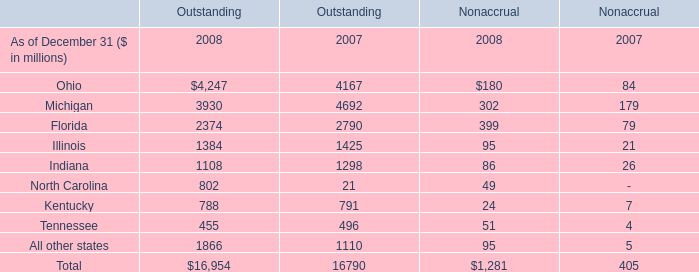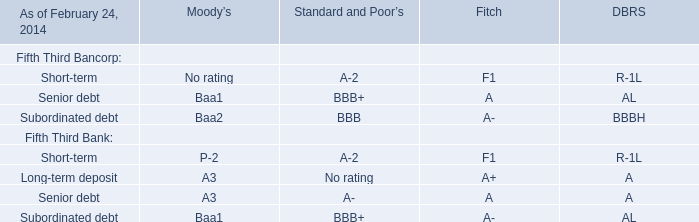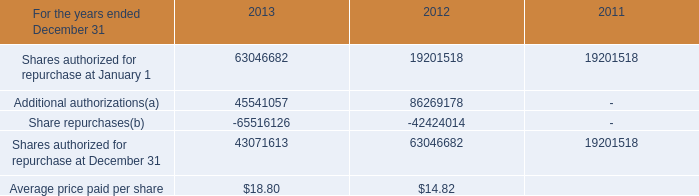What is the growing rate of the Outstanding of Ohio in the year with the least Outstanding of Michigan? 
Computations: ((4247 - 4167) / 4167)
Answer: 0.0192. 